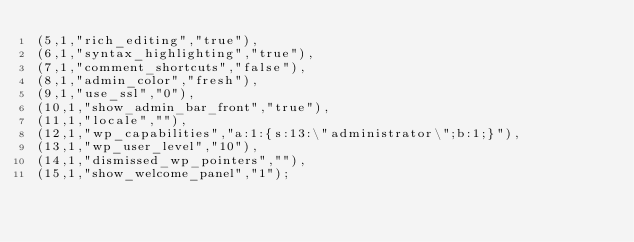<code> <loc_0><loc_0><loc_500><loc_500><_SQL_>(5,1,"rich_editing","true"),
(6,1,"syntax_highlighting","true"),
(7,1,"comment_shortcuts","false"),
(8,1,"admin_color","fresh"),
(9,1,"use_ssl","0"),
(10,1,"show_admin_bar_front","true"),
(11,1,"locale",""),
(12,1,"wp_capabilities","a:1:{s:13:\"administrator\";b:1;}"),
(13,1,"wp_user_level","10"),
(14,1,"dismissed_wp_pointers",""),
(15,1,"show_welcome_panel","1");
</code> 